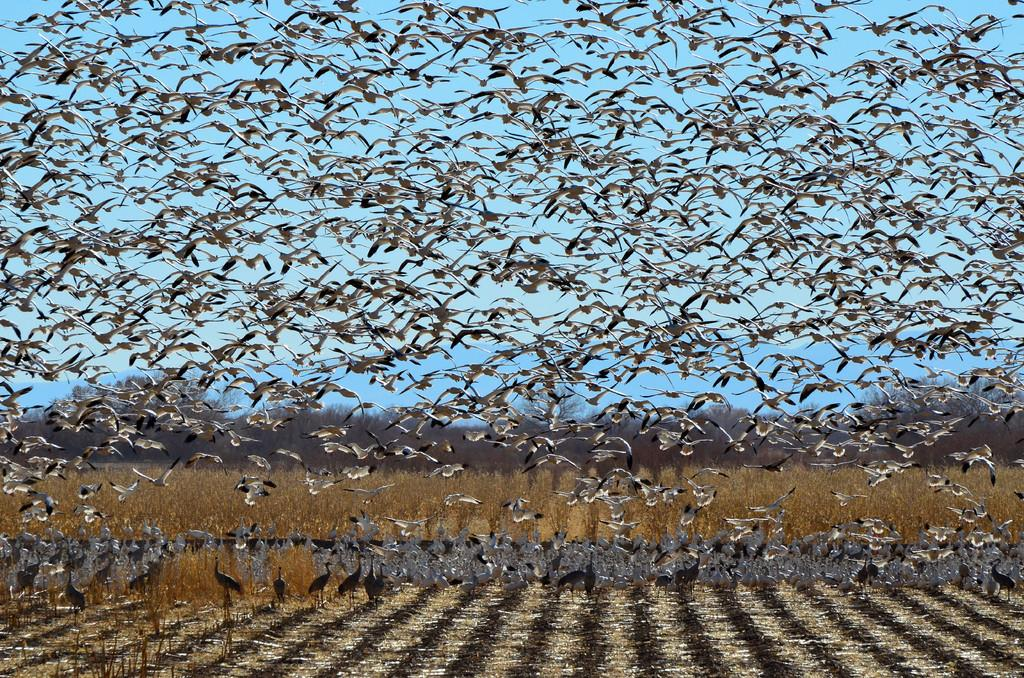What is happening with the birds in the image? There are birds flying in the sky and standing on the ground in the image. What type of vegetation can be seen in the image? There are plants and trees visible in the image. What type of watch is the bird wearing on its leg in the image? There is no watch visible on any bird's leg in the image. 